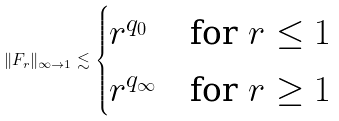Convert formula to latex. <formula><loc_0><loc_0><loc_500><loc_500>\| F _ { r } \| _ { \infty \to 1 } \lesssim \begin{cases} r ^ { q _ { 0 } } & \text {for $r \leq 1$} \\ r ^ { q _ { \infty } } & \text {for $r \geq 1$} \end{cases}</formula> 